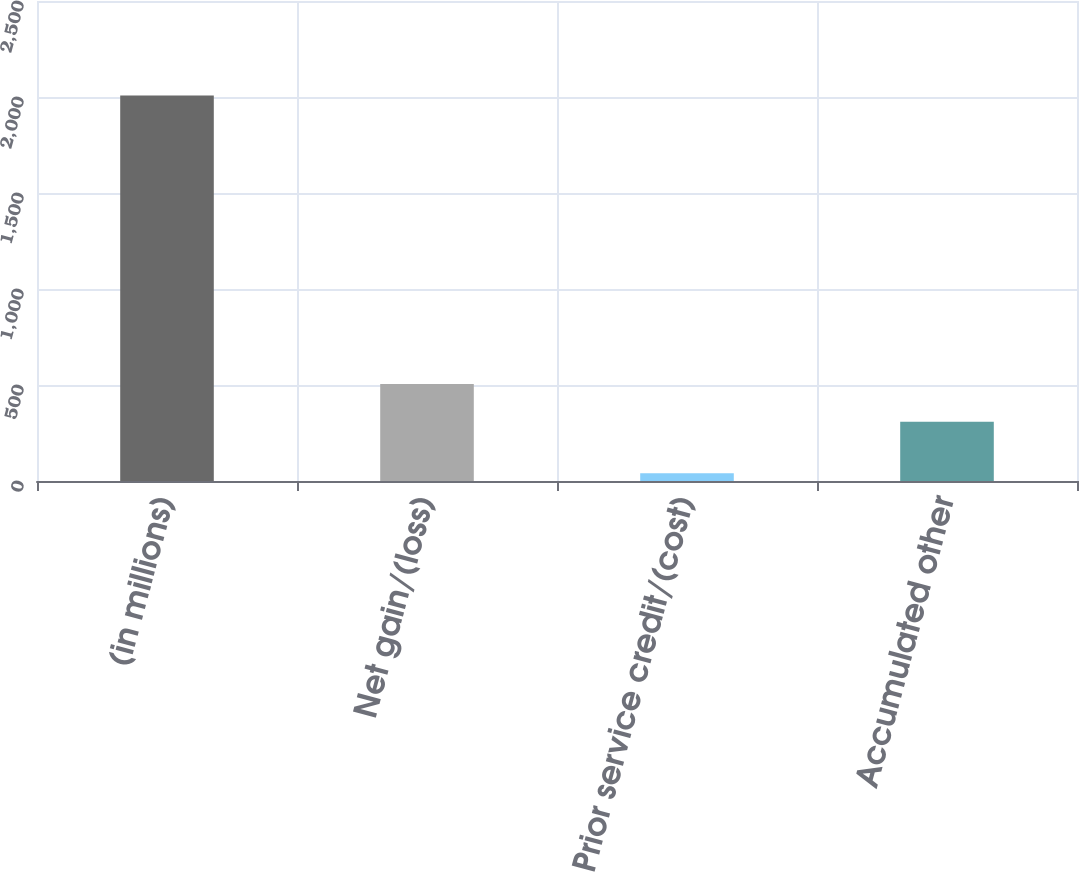<chart> <loc_0><loc_0><loc_500><loc_500><bar_chart><fcel>(in millions)<fcel>Net gain/(loss)<fcel>Prior service credit/(cost)<fcel>Accumulated other<nl><fcel>2008<fcel>505.8<fcel>40<fcel>309<nl></chart> 